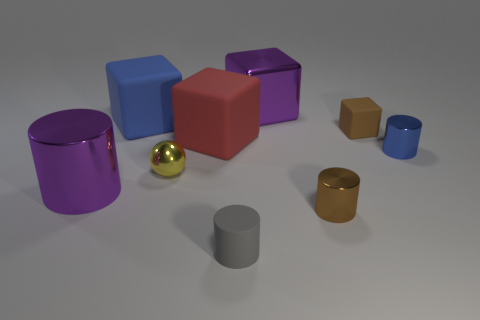Is the color of the ball the same as the large metallic object that is in front of the yellow ball?
Offer a very short reply. No. There is a thing that is to the right of the small rubber block; how many small yellow objects are behind it?
Provide a short and direct response. 0. There is a tiny cylinder behind the purple shiny object to the left of the tiny gray matte thing; what color is it?
Keep it short and to the point. Blue. There is a thing that is both behind the yellow ball and in front of the big red block; what is its material?
Provide a succinct answer. Metal. Is there another small brown metallic object of the same shape as the small brown shiny object?
Your answer should be compact. No. Do the small shiny thing in front of the ball and the yellow shiny thing have the same shape?
Offer a terse response. No. How many blue things are both left of the red thing and in front of the red matte thing?
Keep it short and to the point. 0. There is a rubber object that is right of the purple shiny cube; what shape is it?
Offer a terse response. Cube. What number of big red blocks are made of the same material as the big purple cylinder?
Your answer should be very brief. 0. There is a tiny brown matte thing; is its shape the same as the large shiny object in front of the yellow metal object?
Offer a terse response. No. 